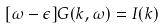Convert formula to latex. <formula><loc_0><loc_0><loc_500><loc_500>[ \omega - \epsilon ] G ( k , \omega ) = I ( k )</formula> 